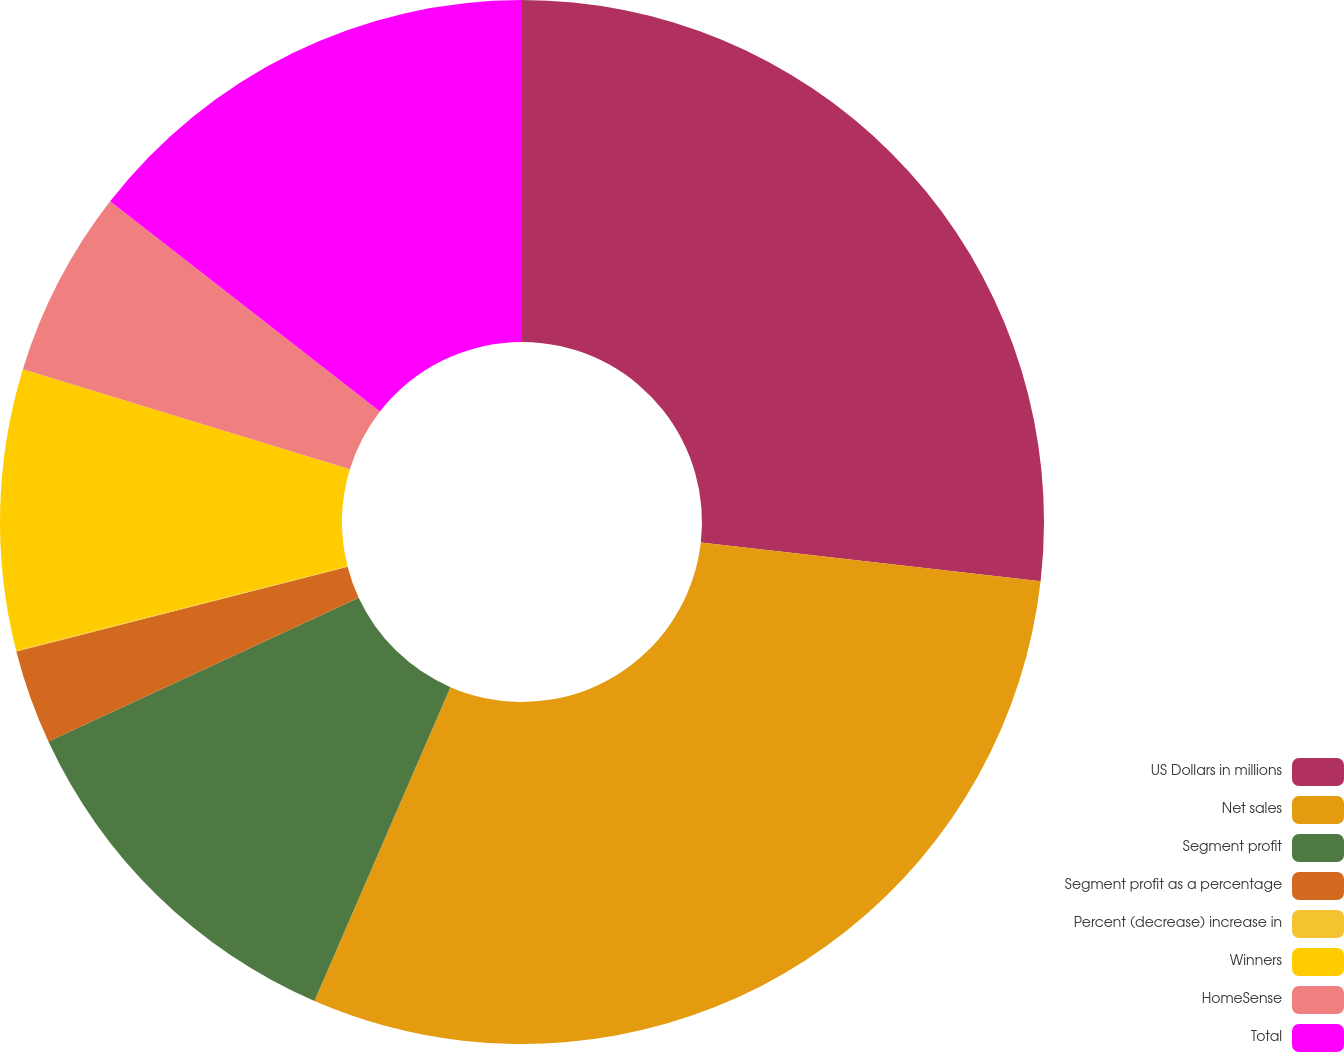<chart> <loc_0><loc_0><loc_500><loc_500><pie_chart><fcel>US Dollars in millions<fcel>Net sales<fcel>Segment profit<fcel>Segment profit as a percentage<fcel>Percent (decrease) increase in<fcel>Winners<fcel>HomeSense<fcel>Total<nl><fcel>26.81%<fcel>29.7%<fcel>11.58%<fcel>2.92%<fcel>0.03%<fcel>8.69%<fcel>5.8%<fcel>14.47%<nl></chart> 